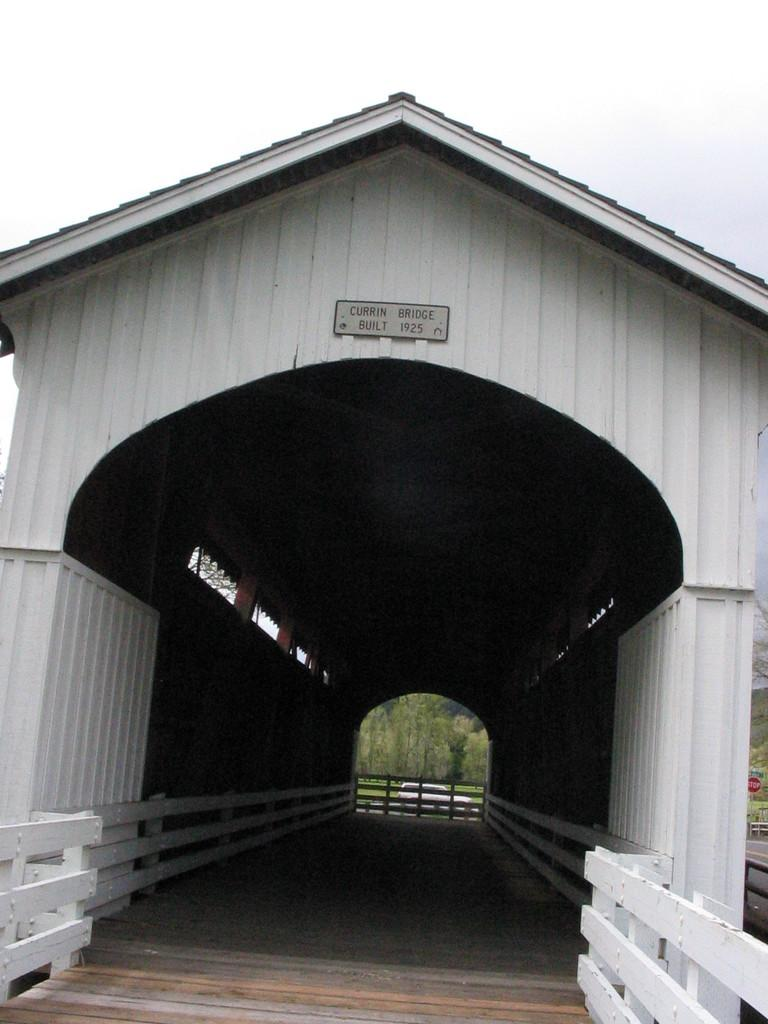What is the main structure in the center of the image? There is a bridge in the center of the image. What is placed on the bridge? There is a board on the bridge. What can be seen in the background of the image? There are trees and a vehicle visible in the background of the image. What type of authority figure can be seen on the board on the bridge? There is no authority figure present on the board on the bridge in the image. How much money is being exchanged between the passenger and the driver of the vehicle in the background? There is no indication of any exchange of money or presence of a passenger in the vehicle in the background of the image. 